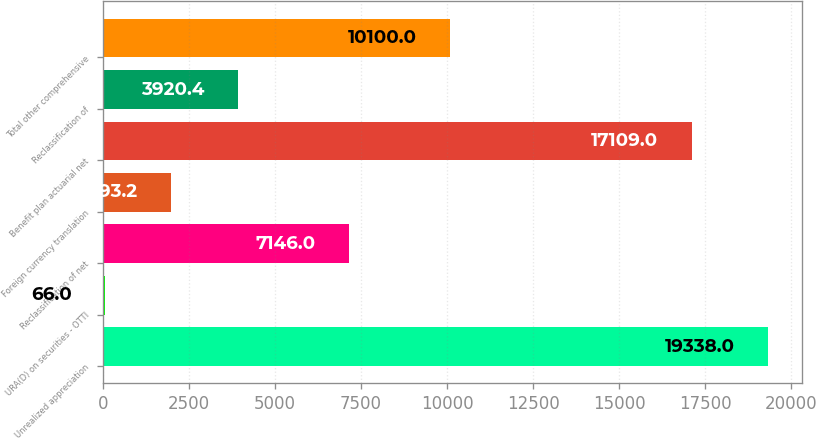Convert chart to OTSL. <chart><loc_0><loc_0><loc_500><loc_500><bar_chart><fcel>Unrealized appreciation<fcel>URA(D) on securities - OTTI<fcel>Reclassification of net<fcel>Foreign currency translation<fcel>Benefit plan actuarial net<fcel>Reclassification of<fcel>Total other comprehensive<nl><fcel>19338<fcel>66<fcel>7146<fcel>1993.2<fcel>17109<fcel>3920.4<fcel>10100<nl></chart> 